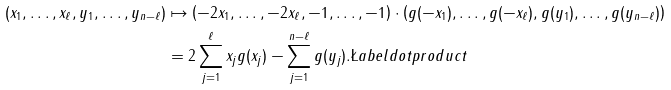<formula> <loc_0><loc_0><loc_500><loc_500>( x _ { 1 } , \dots , x _ { \ell } , y _ { 1 } , \dots , y _ { n - \ell } ) & \mapsto \left ( - 2 x _ { 1 } , \dots , - 2 x _ { \ell } , - 1 , \dots , - 1 \right ) \cdot \left ( g ( - x _ { 1 } ) , \dots , g ( - x _ { \ell } ) , g ( y _ { 1 } ) , \dots , g ( y _ { n - \ell } ) \right ) \\ & = 2 \sum _ { j = 1 } ^ { \ell } x _ { j } g ( x _ { j } ) - \sum _ { j = 1 } ^ { n - \ell } g ( y _ { j } ) . \L a b e l { d o t p r o d u c t }</formula> 